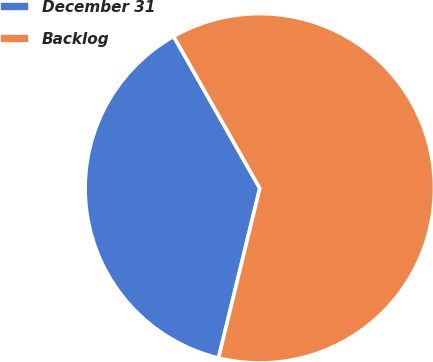Convert chart. <chart><loc_0><loc_0><loc_500><loc_500><pie_chart><fcel>December 31<fcel>Backlog<nl><fcel>37.99%<fcel>62.01%<nl></chart> 